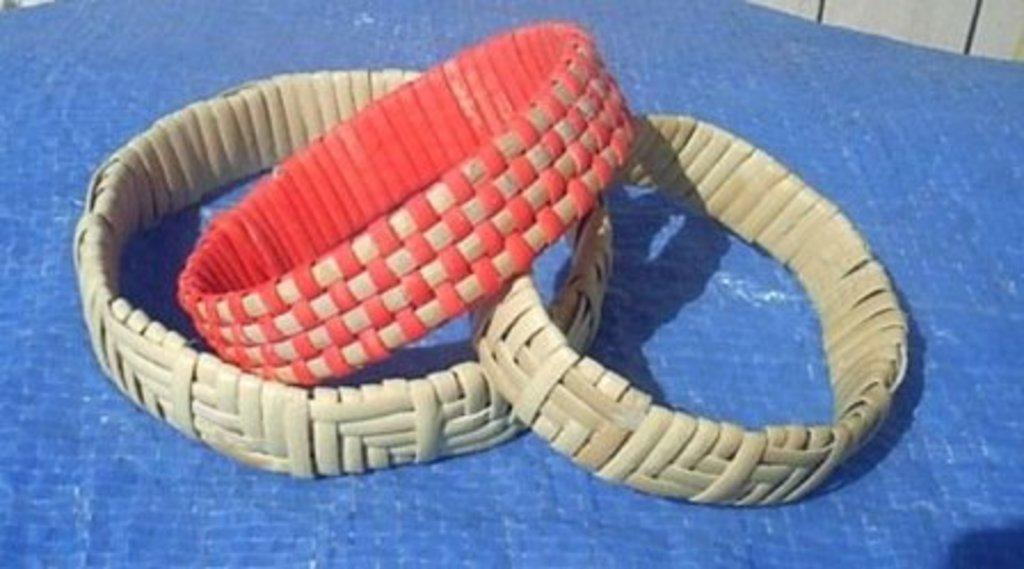What type of accessories are featured in the image? There are hand bracelets in the image. Can you describe the design or style of the hand bracelets? Unfortunately, the image does not provide enough detail to describe the design or style of the hand bracelets. What is the name of the servant who is cooking on the stove in the image? There is no servant or stove present in the image; it only features hand bracelets. 